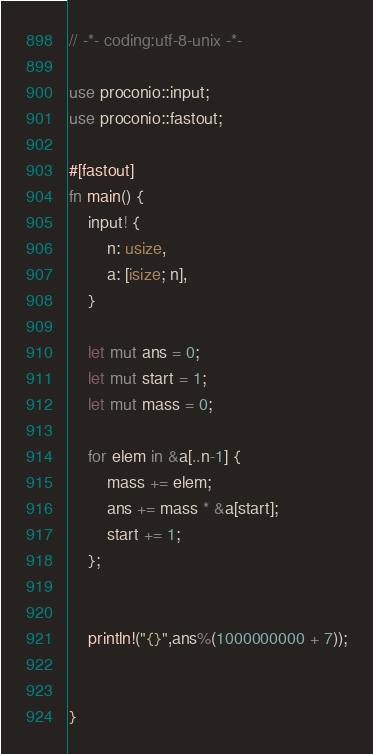Convert code to text. <code><loc_0><loc_0><loc_500><loc_500><_Rust_>// -*- coding:utf-8-unix -*-

use proconio::input;
use proconio::fastout;

#[fastout]
fn main() {
    input! {
        n: usize,
        a: [isize; n],
    }

    let mut ans = 0;
    let mut start = 1;
    let mut mass = 0;

    for elem in &a[..n-1] {
        mass += elem;
        ans += mass * &a[start];
        start += 1;
    };


    println!("{}",ans%(1000000000 + 7));
    
    
}
</code> 